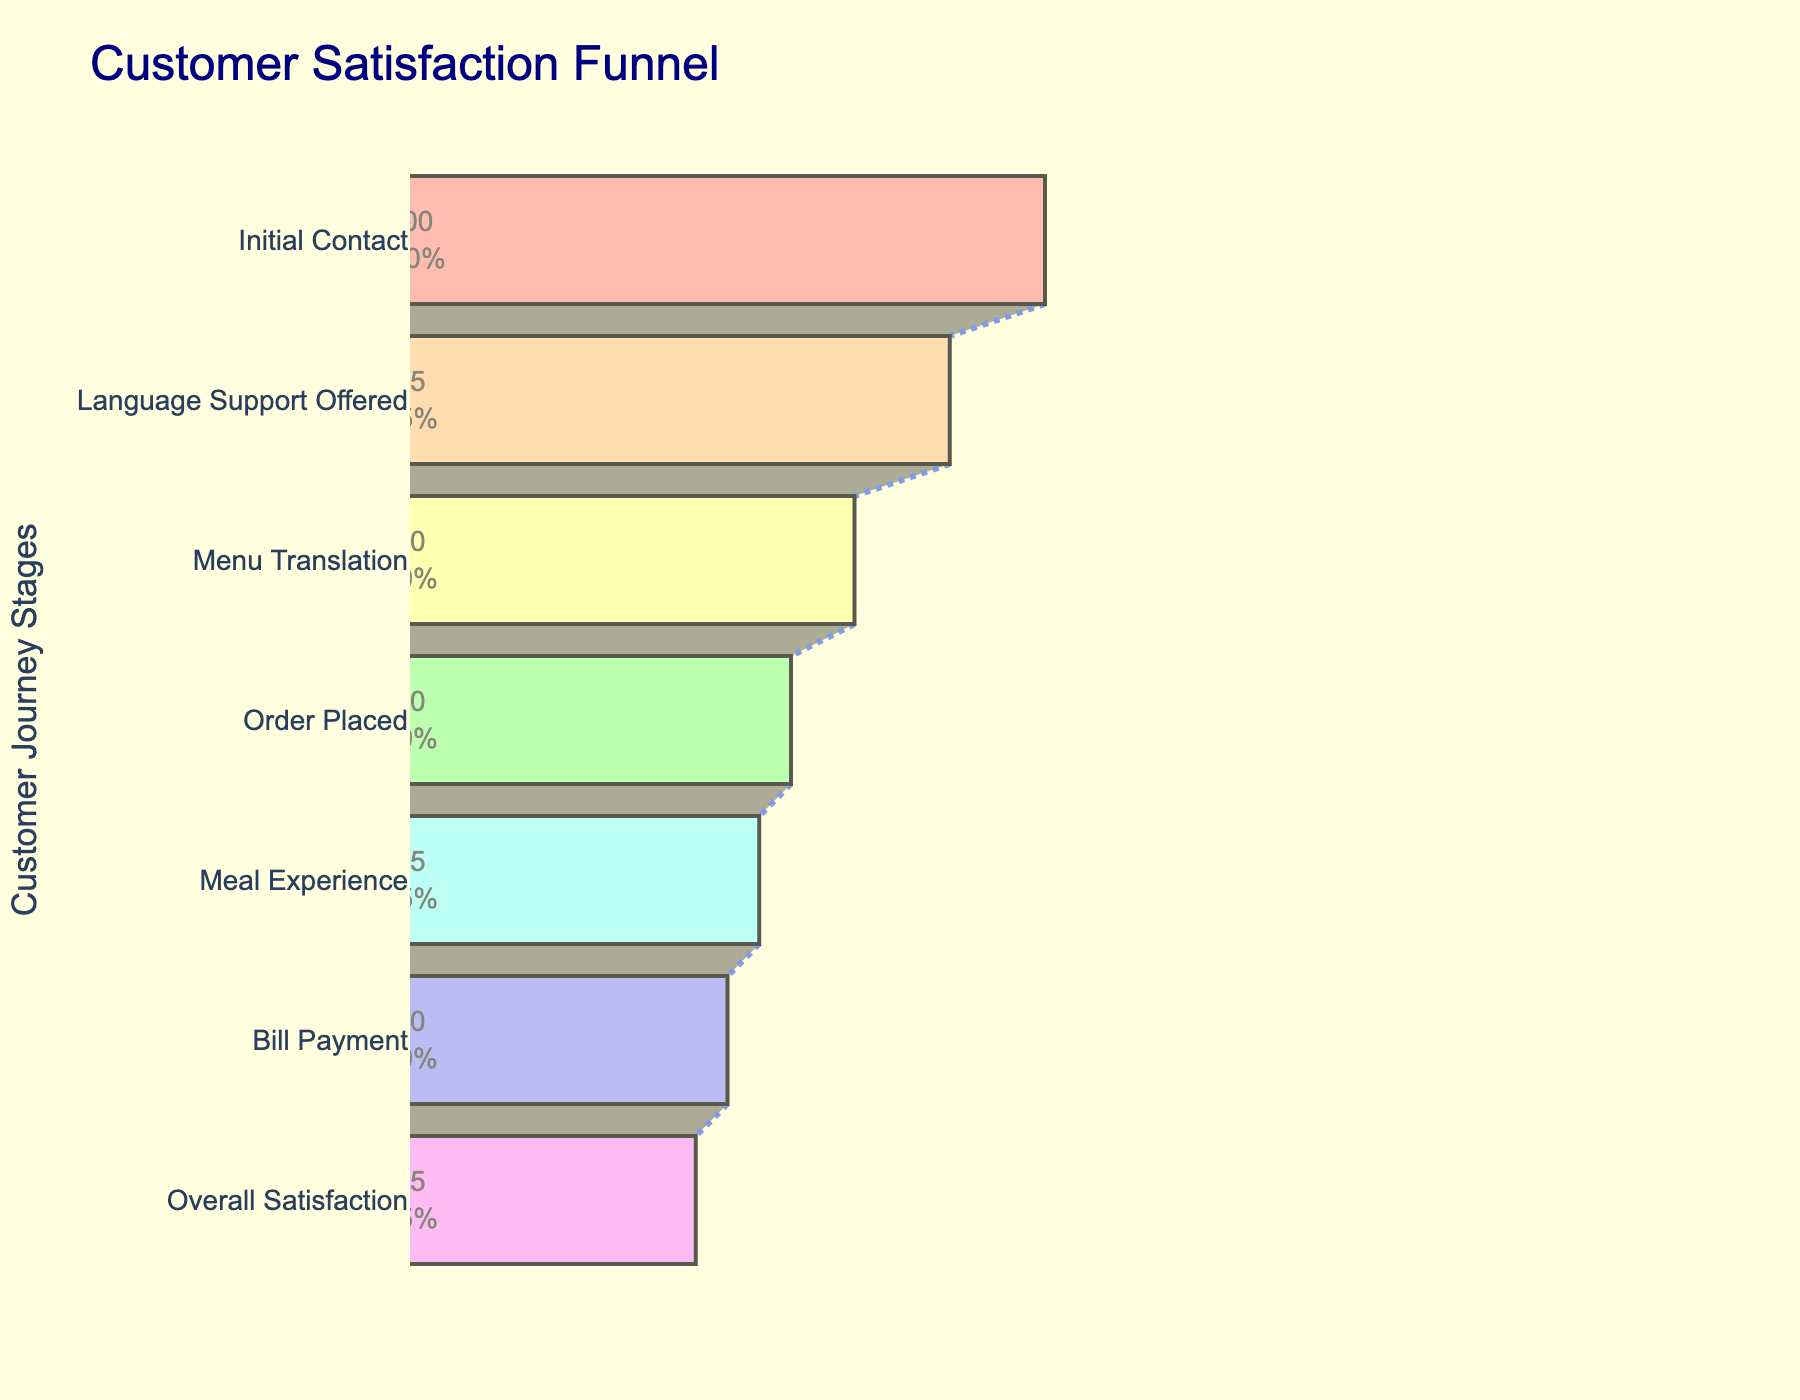What is the title of the funnel chart? The title is usually displayed at the top of the chart. In this case, it reads "Customer Satisfaction Funnel".
Answer: Customer Satisfaction Funnel How many stages are represented in the funnel chart? Count the number of unique stages listed on the y-axis. Here, there are 7 stages.
Answer: 7 What is the satisfaction rate at the 'Language Support Offered' stage? Check the value corresponding to the 'Language Support Offered' stage, which is labeled clearly on the chart. Here, it is 85%.
Answer: 85% What percentage of customers are satisfied after the 'Meal Experience' stage? According to the funnel chart, the satisfaction rate at the 'Meal Experience' stage is 55%.
Answer: 55% What is the overall satisfaction rate of customers? The overall satisfaction rate is shown at the lowest stage of the funnel, which is 45%.
Answer: 45% Which stage shows the biggest drop in customer satisfaction? Subtract the satisfaction rates of consecutive stages and find the largest difference. The biggest drop is between 'Language Support Offered' (85%) and 'Menu Translation' (70%), a difference of 15%.
Answer: Between 'Language Support Offered' and 'Menu Translation' What is the difference in satisfaction rates between the initial contact and the bill payment stages? Calculate the difference: 100% (Initial Contact) - 50% (Bill Payment) = 50%.
Answer: 50% What is the average satisfaction rate across all the stages? Sum all the satisfaction rates and then divide by the number of stages: (100 + 85 + 70 + 60 + 55 + 50 + 45) / 7 ≈ 66.43%.
Answer: 66.43% How much higher is the satisfaction rate at the order placed stage compared to the overall satisfaction rate? Subtract the satisfaction rate at the 'Order Placed' stage from the 'Overall Satisfaction' stage: 60% - 45% = 15%.
Answer: 15% Why might the satisfaction rate drop between 'Menu Translation' and 'Order Placed' stages? Speculate based on typical customer experiences. Transitioning from understanding the menu to completing an order may involve challenges such as miscommunication or errors, potentially leading to a drop in satisfaction.
Answer: Miscommunication/errors 